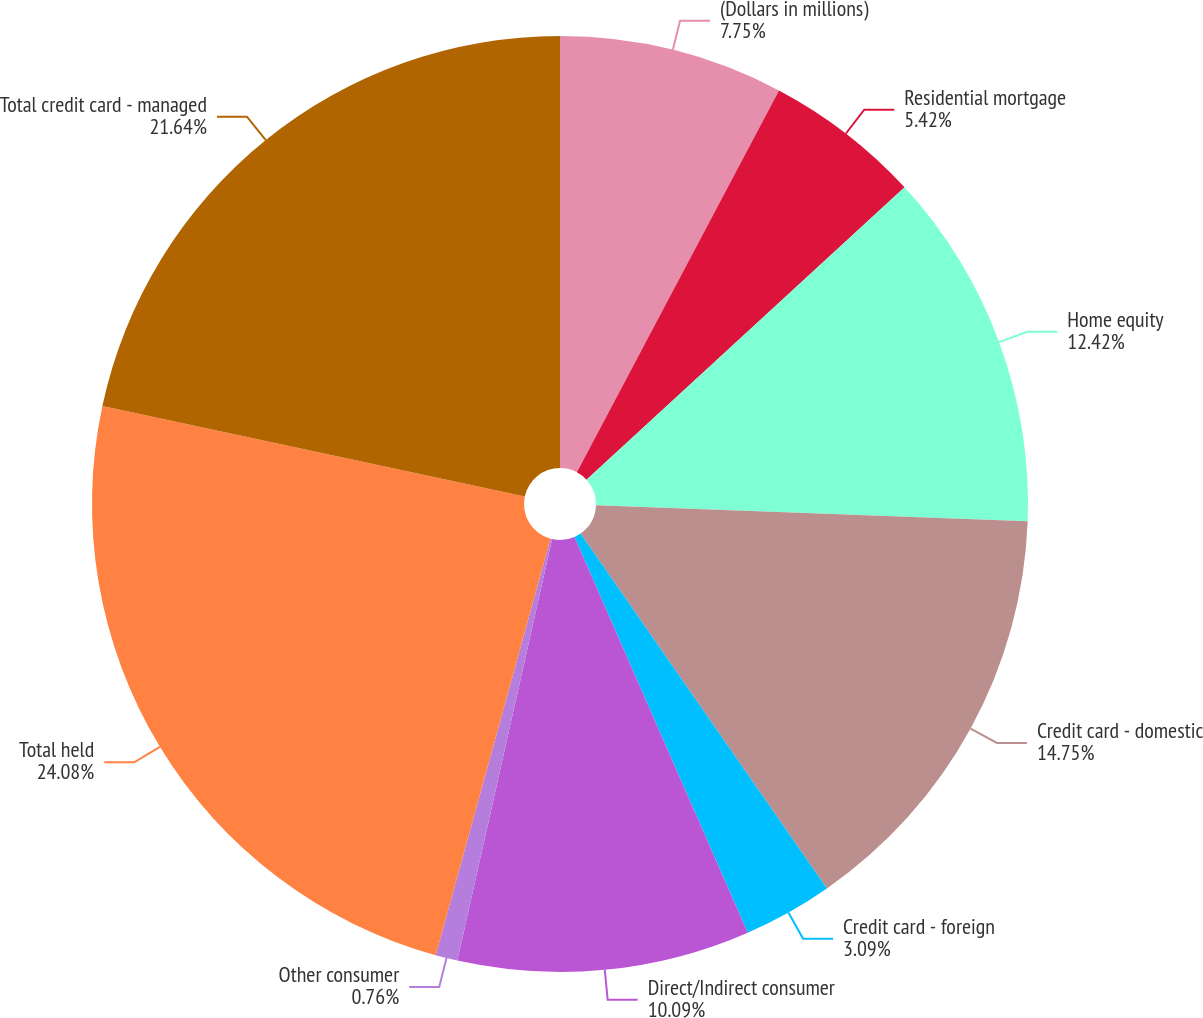<chart> <loc_0><loc_0><loc_500><loc_500><pie_chart><fcel>(Dollars in millions)<fcel>Residential mortgage<fcel>Home equity<fcel>Credit card - domestic<fcel>Credit card - foreign<fcel>Direct/Indirect consumer<fcel>Other consumer<fcel>Total held<fcel>Total credit card - managed<nl><fcel>7.75%<fcel>5.42%<fcel>12.42%<fcel>14.75%<fcel>3.09%<fcel>10.09%<fcel>0.76%<fcel>24.08%<fcel>21.64%<nl></chart> 